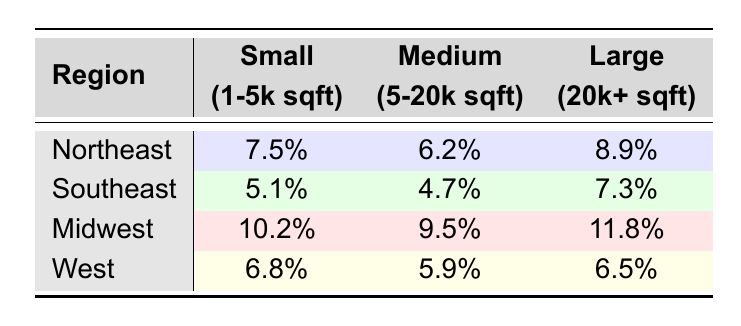What is the vacancy rate for medium-sized properties in the Southeast? The table shows that for medium-sized properties (5-20k sqft) in the Southeast, the vacancy rate is 4.7%.
Answer: 4.7% Which region has the highest vacancy rate for large properties? In the table, the vacancy rates for large properties (20k+ sqft) by region are: Northeast (8.9%), Southeast (7.3%), Midwest (11.8%), and West (6.5%). The highest rate is 11.8% in the Midwest.
Answer: Midwest What is the average vacancy rate for small properties across all regions? The vacancy rates for small properties are: Northeast (7.5%), Southeast (5.1%), Midwest (10.2%), and West (6.8%). Adding these gives 7.5 + 5.1 + 10.2 + 6.8 = 29.6. Dividing by 4 regions gives an average of 29.6 / 4 = 7.4%.
Answer: 7.4% Is the vacancy rate for large properties in the West lower than in the Northeast? The vacancy rates for large properties are: West (6.5%) and Northeast (8.9%). Since 6.5% is less than 8.9%, the statement is true.
Answer: Yes Which property size category shows the least variation in vacancy rates across regions? The vacancy rates for each category are: Small (1-5k sqft): 7.5%, 5.1%, 10.2%, 6.8%; Medium (5-20k sqft): 6.2%, 4.7%, 9.5%, 5.9%; Large (20k+ sqft): 8.9%, 7.3%, 11.8%, 6.5%. Analyzing these, the Medium category shows rates ranging from 4.7% to 9.5%, a range of 4.8%. The Small category has a range of 5.1% and Large has a range of 5.3%. Thus, Medium shows the least variation.
Answer: Medium What is the difference in vacancy rates between large properties in the Midwest and the Southeast? The vacancy rate for large properties in the Midwest is 11.8%, and in the Southeast, it is 7.3%. To find the difference: 11.8% - 7.3% = 4.5%.
Answer: 4.5% 